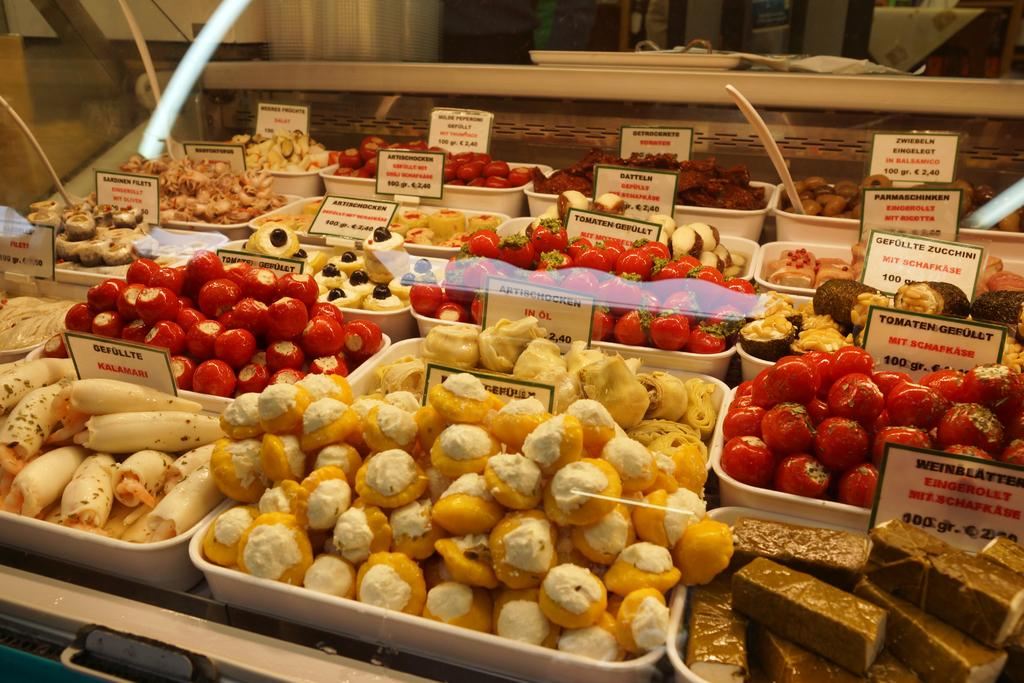How many bowls are visible in the image? There are many bowls in the image. What is in the bowls? There are different sweets in the bowls. What type of scissors are being used to reason in the image? There are no scissors or any reasoning activity present in the image; it features multiple bowls with different sweets. 